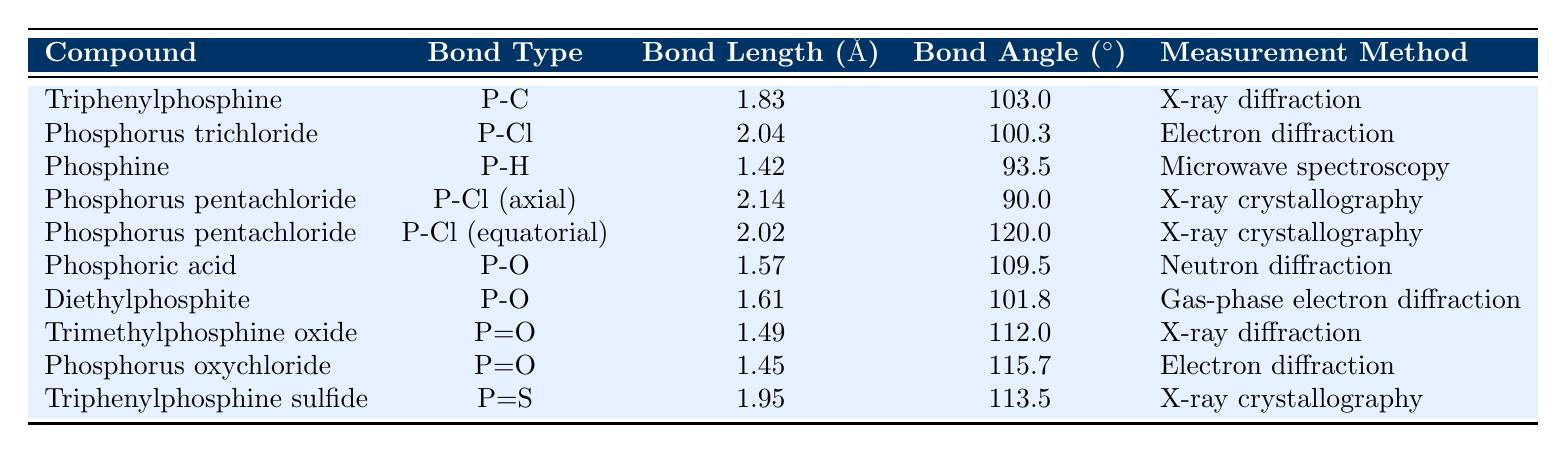What is the bond angle for Phosphine? The bond angle for Phosphine is stated directly in the table as 93.5 degrees.
Answer: 93.5 degrees What measurement method was used for Triphenylphosphine? The measurement method for Triphenylphosphine is listed in the table as X-ray diffraction.
Answer: X-ray diffraction Which compound has the longest P-Cl bond length? By comparing the bond lengths of the compounds with P-Cl bonds, Phosphorus pentachloride (axial) has the longest bond length of 2.14 angstroms.
Answer: Phosphorus pentachloride (axial) What is the average bond length of P-O bonds in the table? The bond lengths of P-O in the table are 1.57 and 1.61 angstroms. Adding them gives 1.57 + 1.61 = 3.18 angstroms, and dividing by 2 (the number of values) gives an average of 1.59 angstroms.
Answer: 1.59 angstroms Is the bond angle for P=O in Phosphorus oxychloride greater than 110 degrees? The bond angle for P=O in Phosphorus oxychloride is 115.7 degrees, which is indeed greater than 110 degrees.
Answer: Yes What compound has the smallest bond length among those listed? The bond length with the smallest value is for Phosphine at 1.42 angstroms.
Answer: Phosphine How many compounds have their bond angles equal to or greater than 100 degrees? From the table, the bond angles that are 100 degrees or greater are: Triphenylphosphine (103.0), Phosphorus trichloride (100.3), Phosphoric acid (109.5), Diethylphosphite (101.8), Trimethylphosphine oxide (112.0), Phosphorus oxychloride (115.7), and Triphenylphosphine sulfide (113.5). This results in a total of 7 compounds.
Answer: 7 compounds What is the difference in bond angle between P-Cl (equatorial) and P-Cl (axial) in Phosphorus pentachloride? The bond angle for P-Cl (equatorial) is 120.0 degrees and for P-Cl (axial) is 90.0 degrees, making the difference 120.0 - 90.0 = 30.0 degrees.
Answer: 30.0 degrees For which compound is the bond angle of 90 degrees observed? The only compound with a bond angle of 90.0 degrees is Phosphorus pentachloride in its axial configuration.
Answer: Phosphorus pentachloride (axial) Which phosphorus-containing compound has two different bond angles listed? Phosphorus pentachloride has two bond angles listed: 90.0 degrees for the axial bond and 120.0 degrees for the equatorial bond.
Answer: Phosphorus pentachloride 